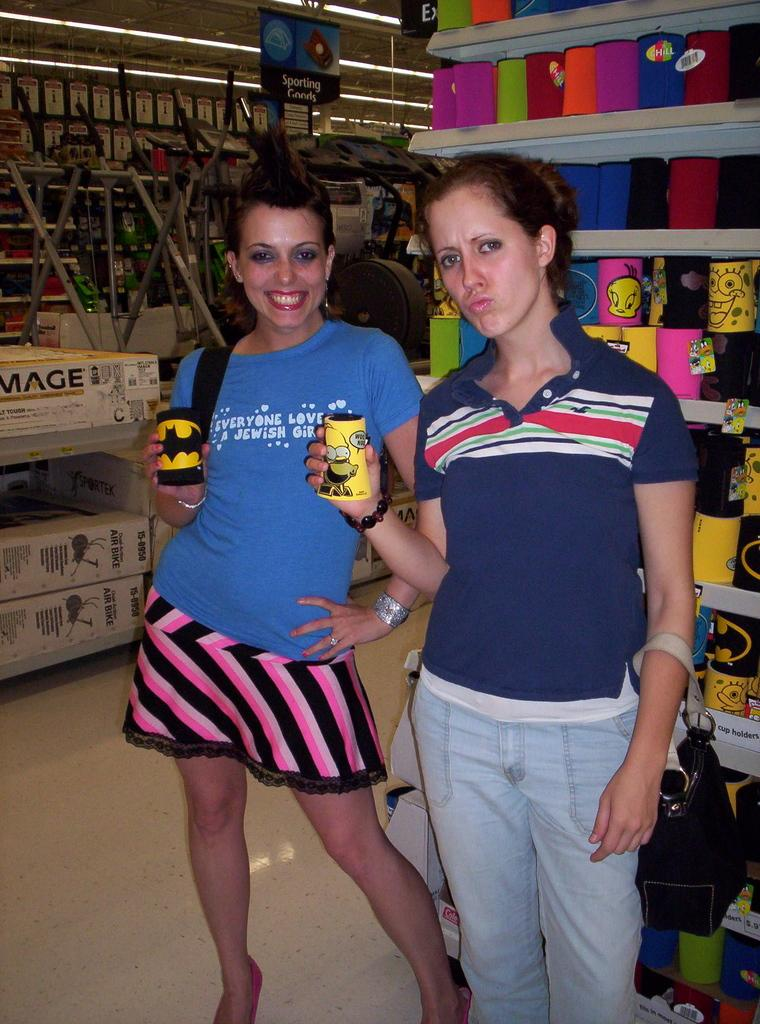<image>
Give a short and clear explanation of the subsequent image. A girl has a shirt on it with the word Jewish. 